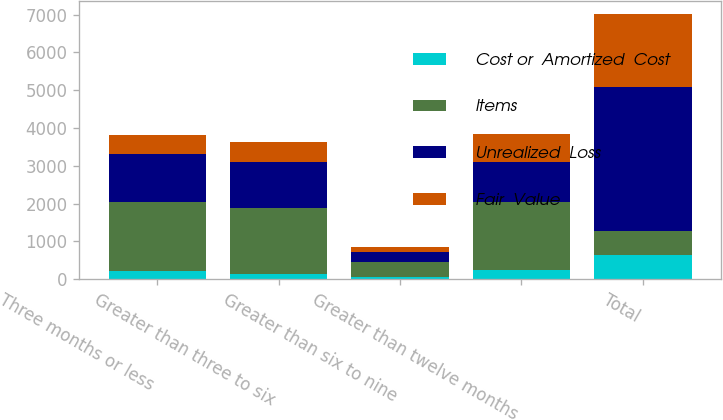Convert chart to OTSL. <chart><loc_0><loc_0><loc_500><loc_500><stacked_bar_chart><ecel><fcel>Three months or less<fcel>Greater than three to six<fcel>Greater than six to nine<fcel>Greater than twelve months<fcel>Total<nl><fcel>Cost or  Amortized  Cost<fcel>206<fcel>134<fcel>42<fcel>239<fcel>630<nl><fcel>Items<fcel>1823<fcel>1749<fcel>406<fcel>1806<fcel>630<nl><fcel>Unrealized  Loss<fcel>1289<fcel>1205<fcel>269<fcel>1057<fcel>3820<nl><fcel>Fair  Value<fcel>500<fcel>544<fcel>137<fcel>749<fcel>1931<nl></chart> 